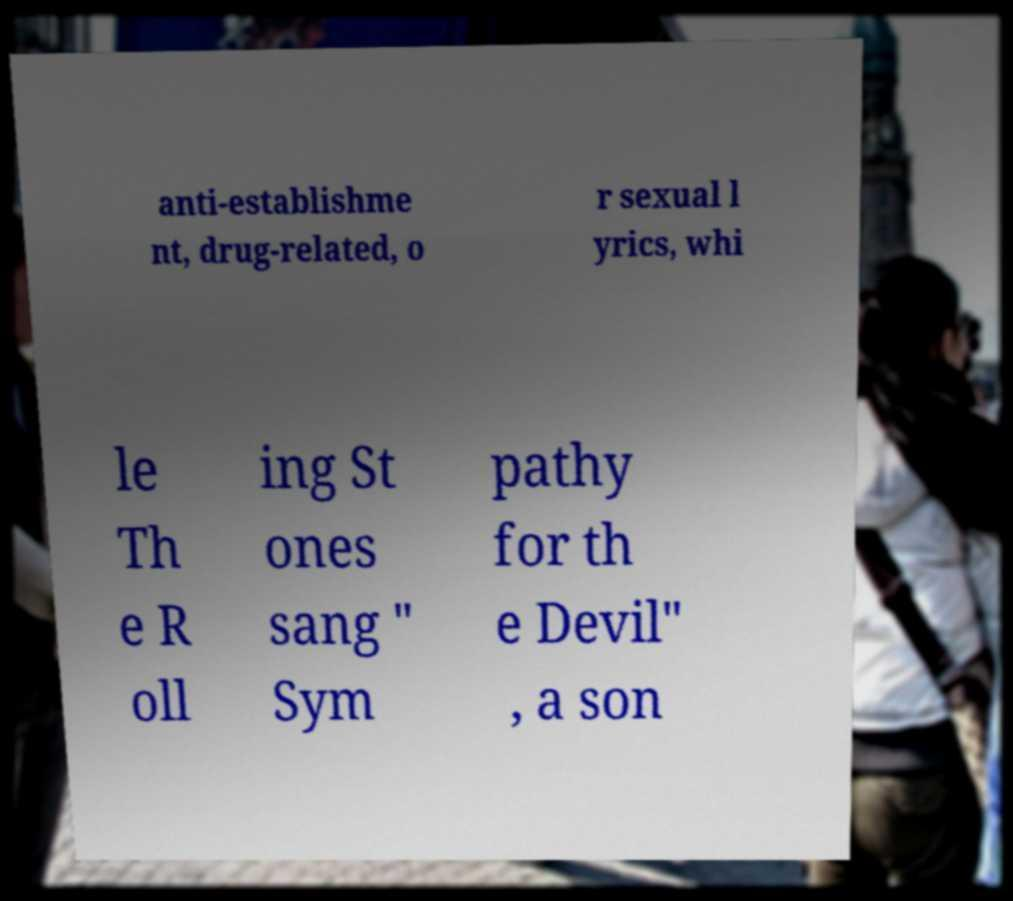Can you read and provide the text displayed in the image?This photo seems to have some interesting text. Can you extract and type it out for me? anti-establishme nt, drug-related, o r sexual l yrics, whi le Th e R oll ing St ones sang " Sym pathy for th e Devil" , a son 